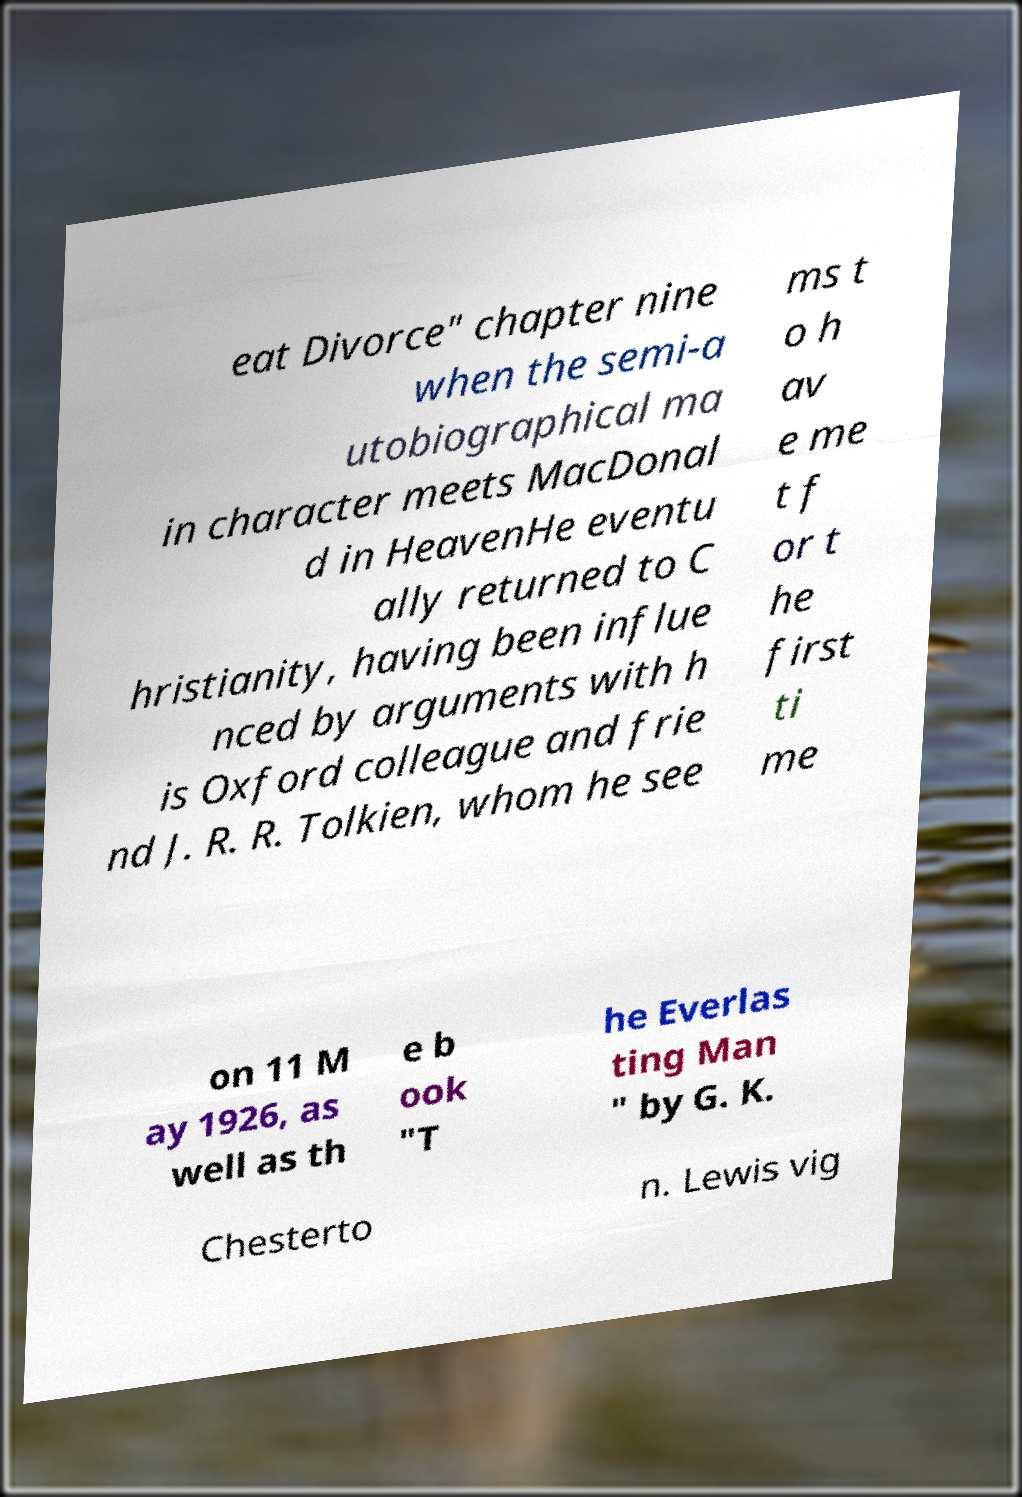Could you extract and type out the text from this image? eat Divorce" chapter nine when the semi-a utobiographical ma in character meets MacDonal d in HeavenHe eventu ally returned to C hristianity, having been influe nced by arguments with h is Oxford colleague and frie nd J. R. R. Tolkien, whom he see ms t o h av e me t f or t he first ti me on 11 M ay 1926, as well as th e b ook "T he Everlas ting Man " by G. K. Chesterto n. Lewis vig 